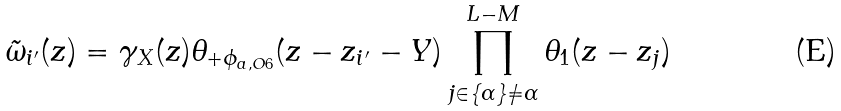<formula> <loc_0><loc_0><loc_500><loc_500>\tilde { \omega } _ { i ^ { \prime } } ( z ) = \gamma _ { X } ( z ) \theta _ { + \phi _ { a , O 6 } } ( z - z _ { i ^ { \prime } } - Y ) \prod _ { j \in \{ \alpha \} \ne \alpha } ^ { L - M } \theta _ { 1 } ( z - z _ { j } )</formula> 